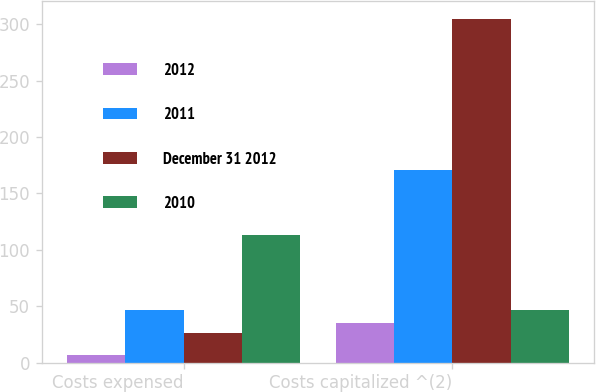<chart> <loc_0><loc_0><loc_500><loc_500><stacked_bar_chart><ecel><fcel>Costs expensed<fcel>Costs capitalized ^(2)<nl><fcel>2012<fcel>7<fcel>35<nl><fcel>2011<fcel>47<fcel>171<nl><fcel>December 31 2012<fcel>26<fcel>305<nl><fcel>2010<fcel>113<fcel>47<nl></chart> 